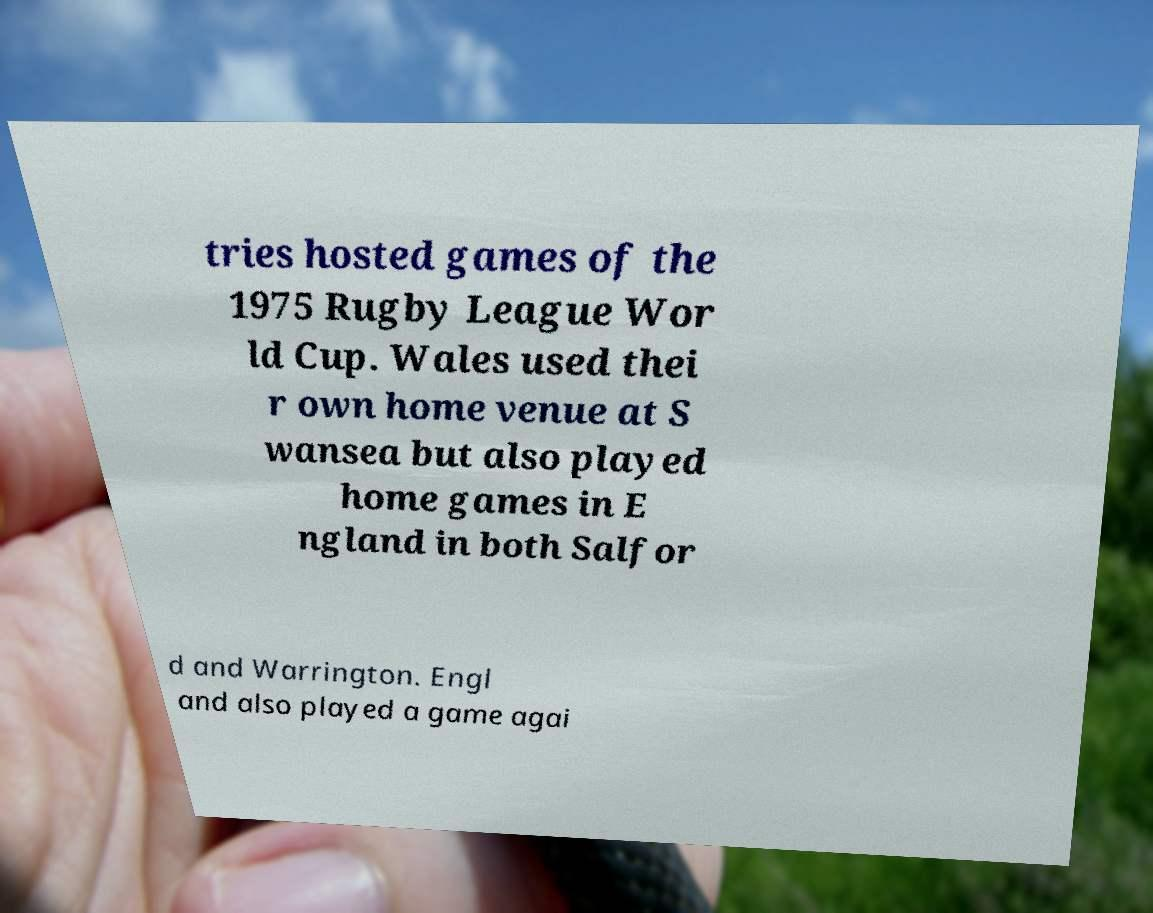Please identify and transcribe the text found in this image. tries hosted games of the 1975 Rugby League Wor ld Cup. Wales used thei r own home venue at S wansea but also played home games in E ngland in both Salfor d and Warrington. Engl and also played a game agai 